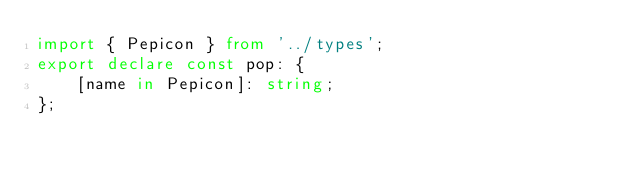Convert code to text. <code><loc_0><loc_0><loc_500><loc_500><_TypeScript_>import { Pepicon } from '../types';
export declare const pop: {
    [name in Pepicon]: string;
};
</code> 